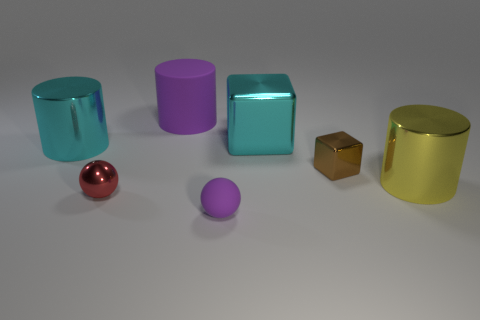Add 2 large yellow metallic things. How many objects exist? 9 Subtract all big cyan metal cylinders. How many cylinders are left? 2 Subtract all yellow cylinders. How many cylinders are left? 2 Subtract all cylinders. How many objects are left? 4 Subtract all tiny rubber things. Subtract all yellow cylinders. How many objects are left? 5 Add 4 big cyan shiny cylinders. How many big cyan shiny cylinders are left? 5 Add 6 cyan cylinders. How many cyan cylinders exist? 7 Subtract 1 cyan cubes. How many objects are left? 6 Subtract 3 cylinders. How many cylinders are left? 0 Subtract all yellow spheres. Subtract all gray cylinders. How many spheres are left? 2 